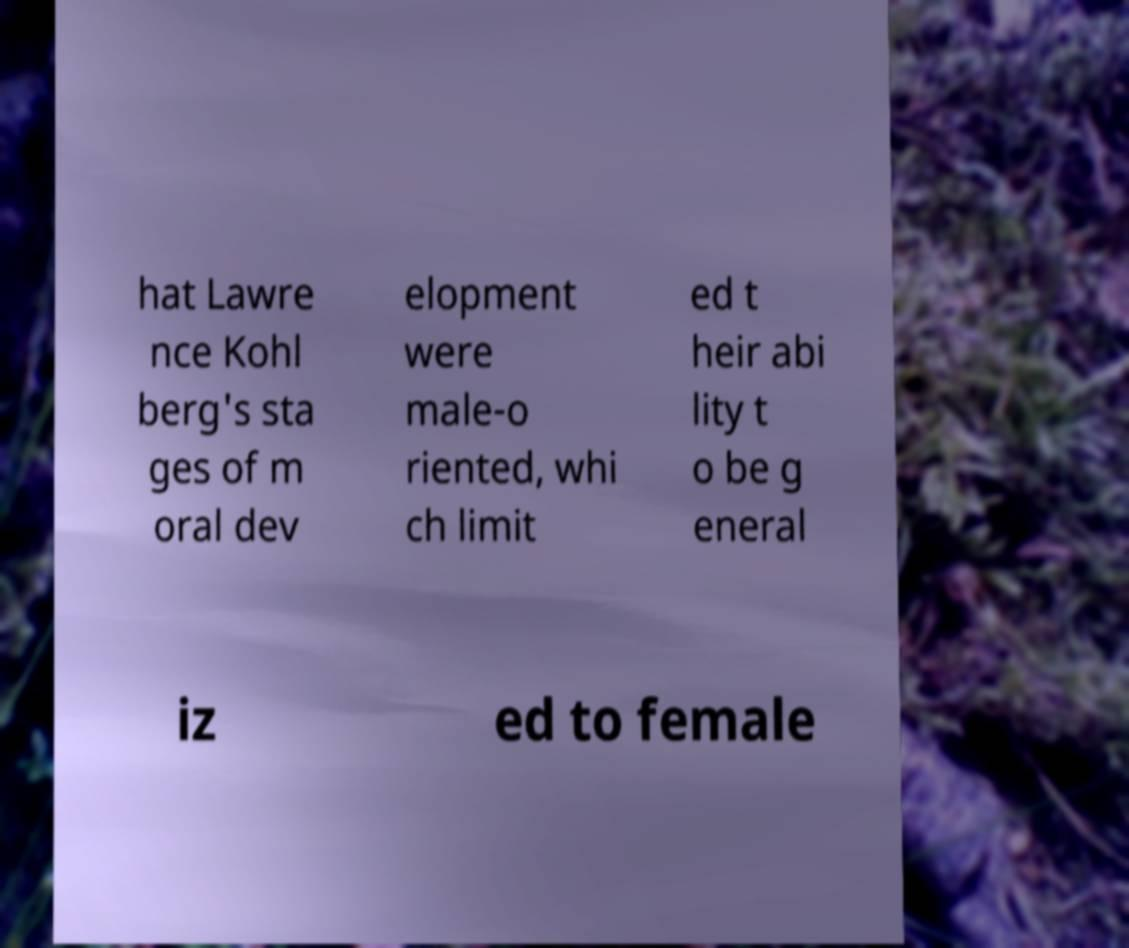For documentation purposes, I need the text within this image transcribed. Could you provide that? hat Lawre nce Kohl berg's sta ges of m oral dev elopment were male-o riented, whi ch limit ed t heir abi lity t o be g eneral iz ed to female 